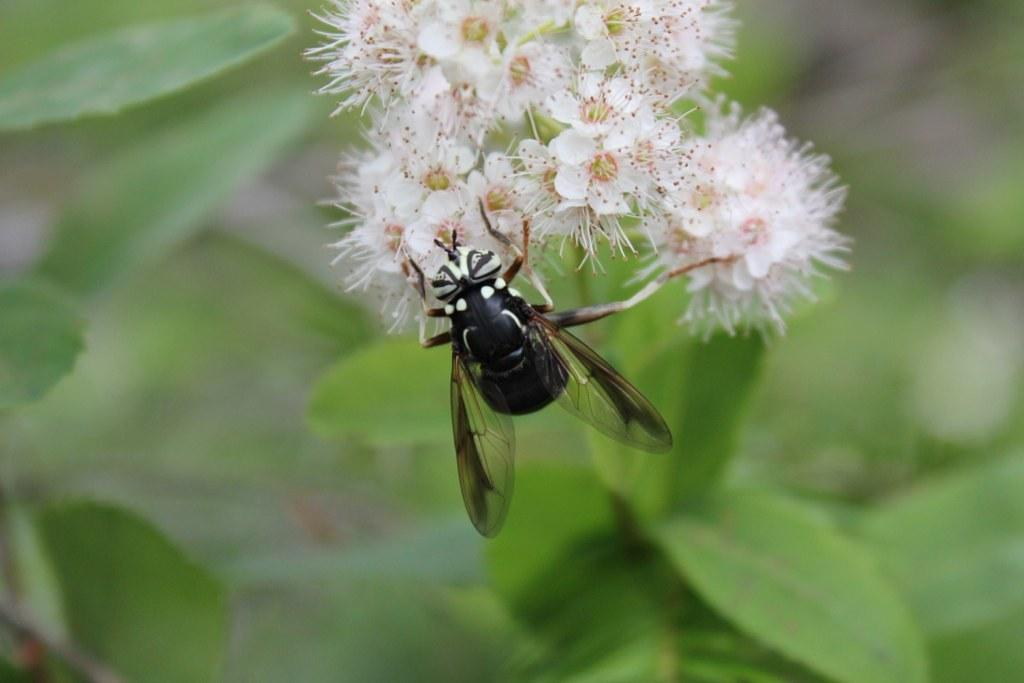What is the main subject in the center of the image? There is a plant with flowers in the center of the image. Can you describe any additional details about the plant? There is an insect on one of the flowers. How would you describe the overall appearance of the image? The background of the image is blurred. What type of wound can be seen on the insect in the image? There is no wound visible on the insect in the image. What kind of meat is being stored in the cellar in the image? There is no cellar or meat present in the image; it features a plant with flowers and an insect. 